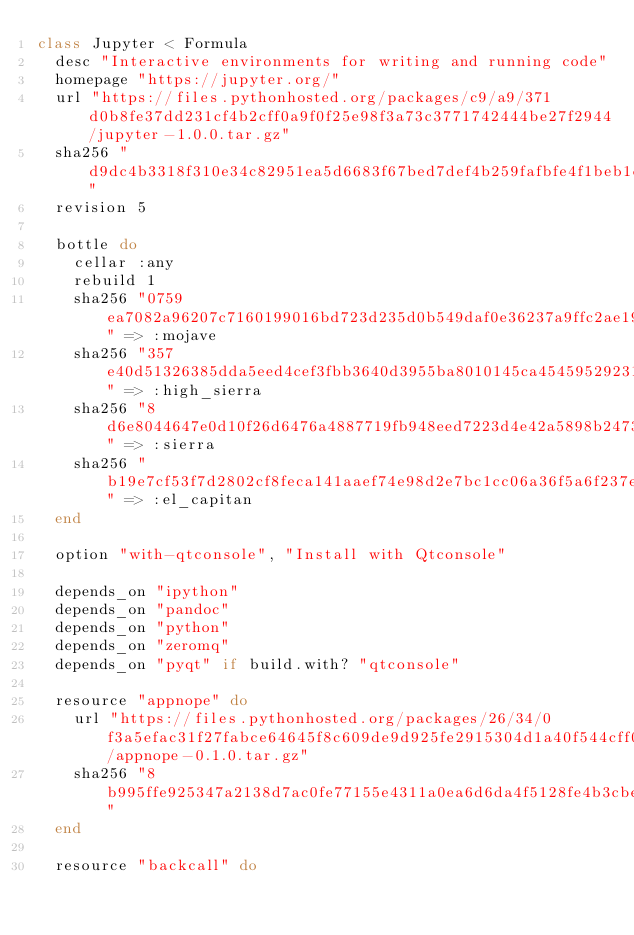<code> <loc_0><loc_0><loc_500><loc_500><_Ruby_>class Jupyter < Formula
  desc "Interactive environments for writing and running code"
  homepage "https://jupyter.org/"
  url "https://files.pythonhosted.org/packages/c9/a9/371d0b8fe37dd231cf4b2cff0a9f0f25e98f3a73c3771742444be27f2944/jupyter-1.0.0.tar.gz"
  sha256 "d9dc4b3318f310e34c82951ea5d6683f67bed7def4b259fafbfe4f1beb1d8e5f"
  revision 5

  bottle do
    cellar :any
    rebuild 1
    sha256 "0759ea7082a96207c7160199016bd723d235d0b549daf0e36237a9ffc2ae1982" => :mojave
    sha256 "357e40d51326385dda5eed4cef3fbb3640d3955ba8010145ca45459529231114" => :high_sierra
    sha256 "8d6e8044647e0d10f26d6476a4887719fb948eed7223d4e42a5898b247335228" => :sierra
    sha256 "b19e7cf53f7d2802cf8feca141aaef74e98d2e7bc1cc06a36f5a6f237e29848a" => :el_capitan
  end

  option "with-qtconsole", "Install with Qtconsole"

  depends_on "ipython"
  depends_on "pandoc"
  depends_on "python"
  depends_on "zeromq"
  depends_on "pyqt" if build.with? "qtconsole"

  resource "appnope" do
    url "https://files.pythonhosted.org/packages/26/34/0f3a5efac31f27fabce64645f8c609de9d925fe2915304d1a40f544cff0e/appnope-0.1.0.tar.gz"
    sha256 "8b995ffe925347a2138d7ac0fe77155e4311a0ea6d6da4f5128fe4b3cbe5ed71"
  end

  resource "backcall" do</code> 